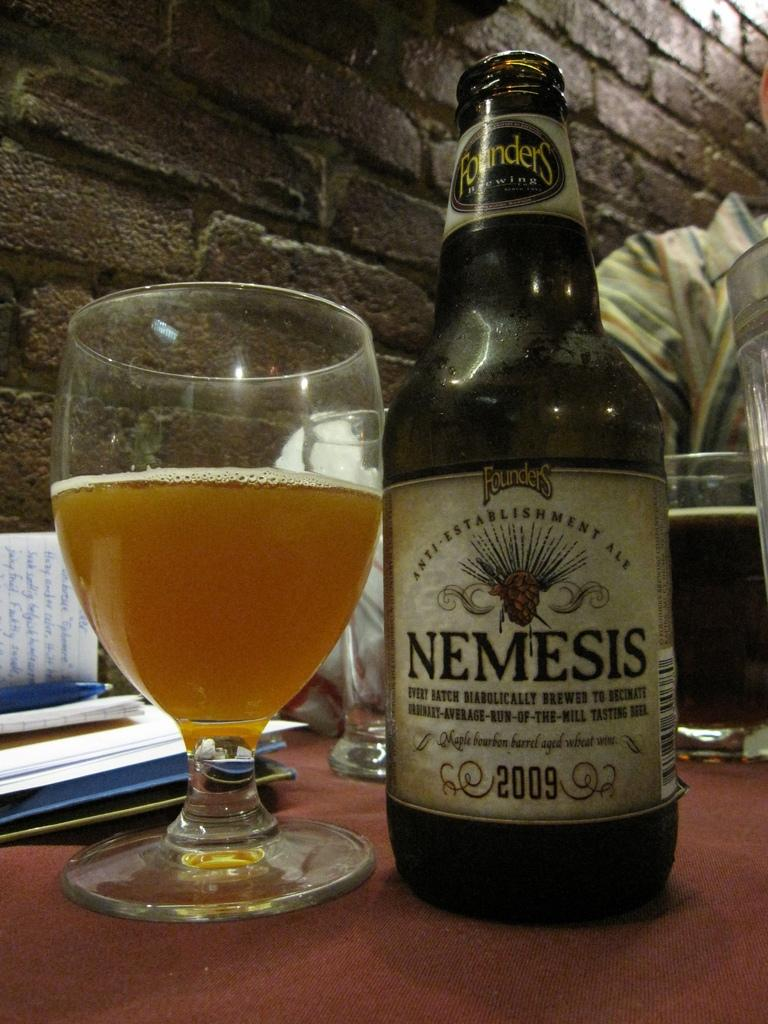<image>
Describe the image concisely. A bottle of Nemesis is next to a glass that is half full. 